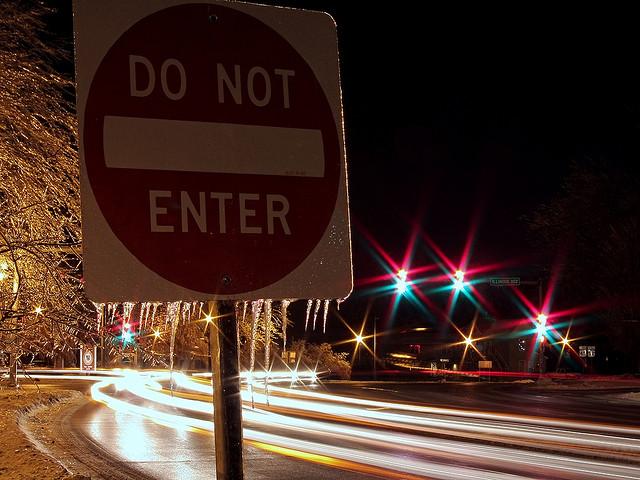Is the road a one way street?
Keep it brief. Yes. Is it hot or cold at the location in this scene?
Short answer required. Cold. Will a lot of cars pass by?
Be succinct. Yes. 